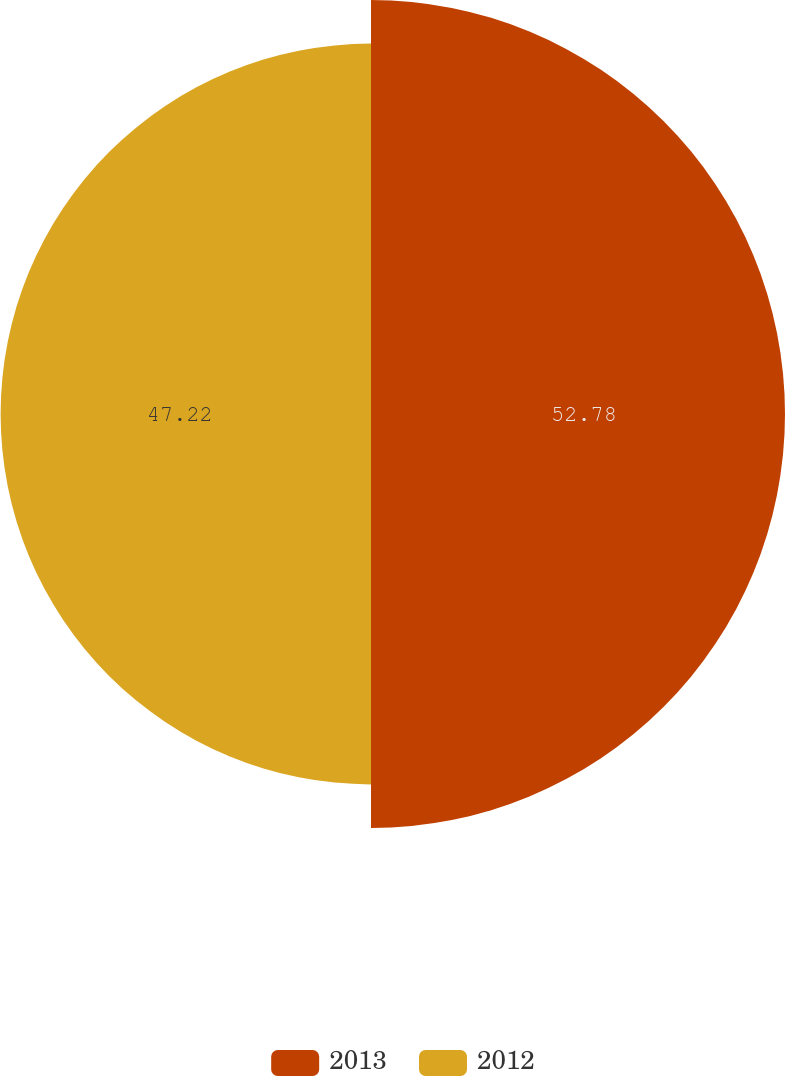<chart> <loc_0><loc_0><loc_500><loc_500><pie_chart><fcel>2013<fcel>2012<nl><fcel>52.78%<fcel>47.22%<nl></chart> 